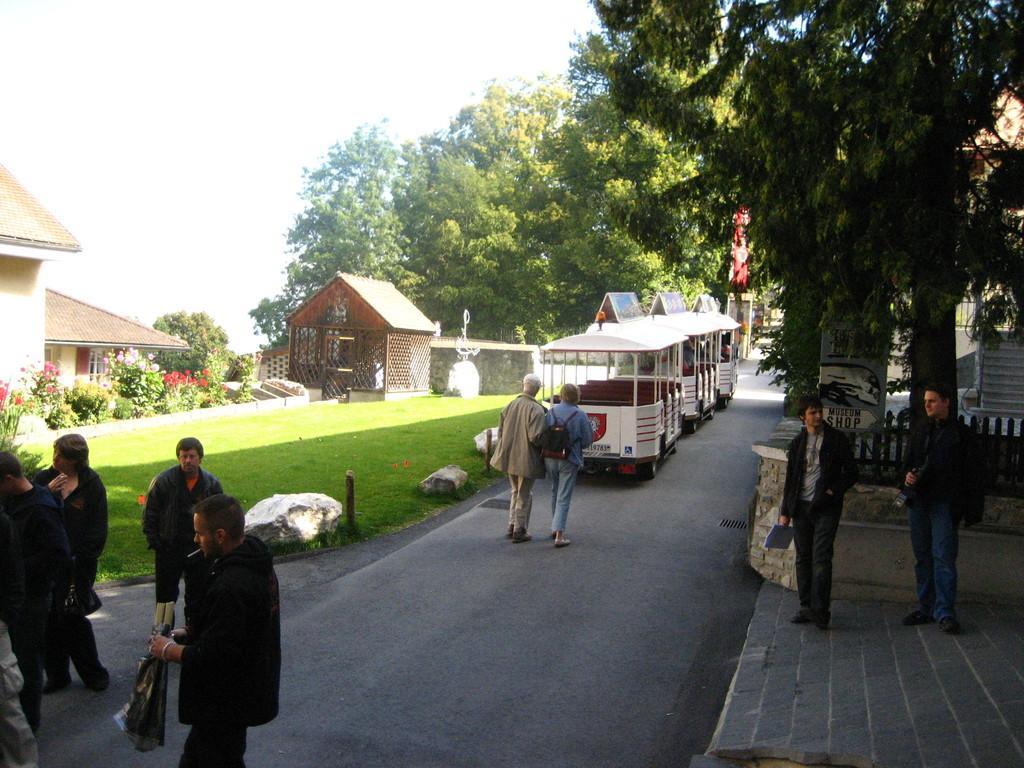Can you describe this image briefly? This is the picture of a place where we have some vehicles and some people on the road and around there are some houses, plants and some grass on the floor and to the side there is a tree and some people on the path. 